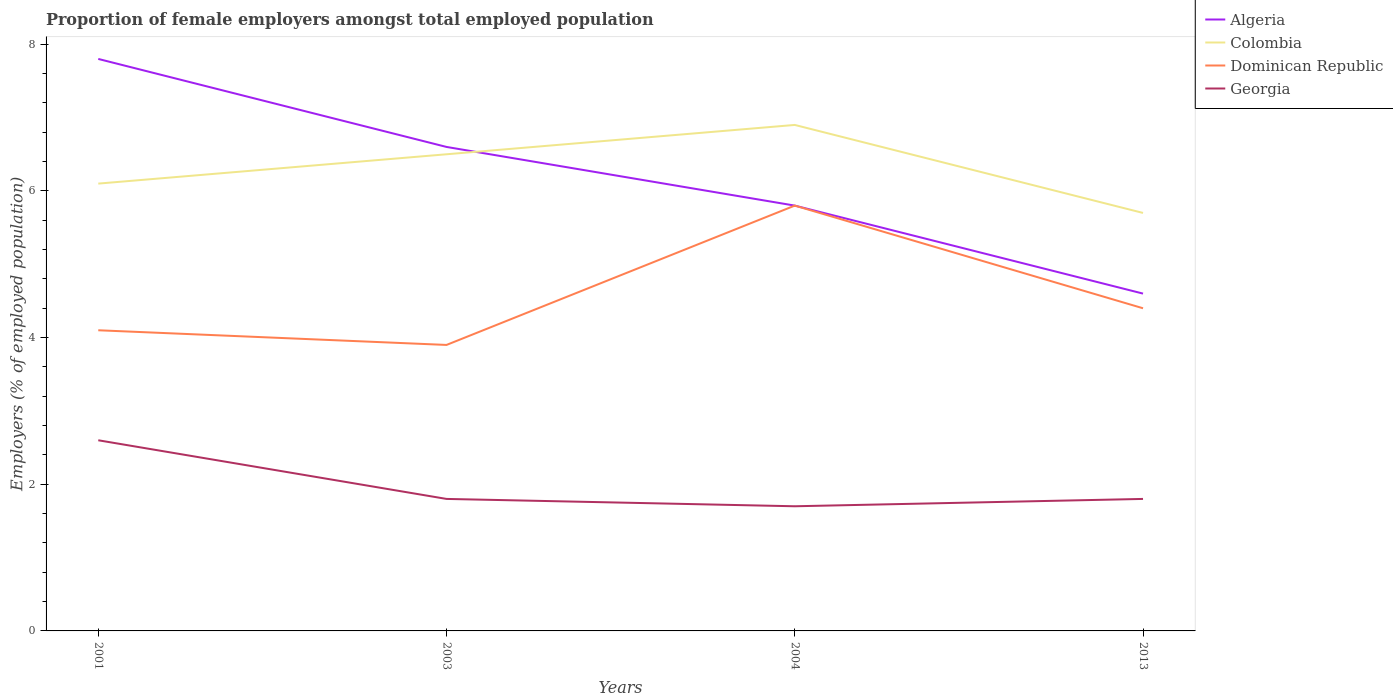How many different coloured lines are there?
Keep it short and to the point. 4. Across all years, what is the maximum proportion of female employers in Dominican Republic?
Keep it short and to the point. 3.9. What is the total proportion of female employers in Dominican Republic in the graph?
Your response must be concise. -0.5. What is the difference between the highest and the second highest proportion of female employers in Georgia?
Ensure brevity in your answer.  0.9. What is the difference between the highest and the lowest proportion of female employers in Colombia?
Keep it short and to the point. 2. Is the proportion of female employers in Georgia strictly greater than the proportion of female employers in Dominican Republic over the years?
Ensure brevity in your answer.  Yes. How many years are there in the graph?
Offer a terse response. 4. What is the difference between two consecutive major ticks on the Y-axis?
Offer a very short reply. 2. Are the values on the major ticks of Y-axis written in scientific E-notation?
Offer a very short reply. No. Does the graph contain grids?
Your answer should be compact. No. What is the title of the graph?
Provide a short and direct response. Proportion of female employers amongst total employed population. Does "Bosnia and Herzegovina" appear as one of the legend labels in the graph?
Provide a short and direct response. No. What is the label or title of the X-axis?
Ensure brevity in your answer.  Years. What is the label or title of the Y-axis?
Your response must be concise. Employers (% of employed population). What is the Employers (% of employed population) in Algeria in 2001?
Make the answer very short. 7.8. What is the Employers (% of employed population) in Colombia in 2001?
Provide a short and direct response. 6.1. What is the Employers (% of employed population) in Dominican Republic in 2001?
Ensure brevity in your answer.  4.1. What is the Employers (% of employed population) in Georgia in 2001?
Offer a very short reply. 2.6. What is the Employers (% of employed population) of Algeria in 2003?
Make the answer very short. 6.6. What is the Employers (% of employed population) in Dominican Republic in 2003?
Offer a terse response. 3.9. What is the Employers (% of employed population) of Georgia in 2003?
Your answer should be very brief. 1.8. What is the Employers (% of employed population) of Algeria in 2004?
Make the answer very short. 5.8. What is the Employers (% of employed population) of Colombia in 2004?
Provide a succinct answer. 6.9. What is the Employers (% of employed population) in Dominican Republic in 2004?
Your answer should be very brief. 5.8. What is the Employers (% of employed population) in Georgia in 2004?
Make the answer very short. 1.7. What is the Employers (% of employed population) in Algeria in 2013?
Make the answer very short. 4.6. What is the Employers (% of employed population) of Colombia in 2013?
Keep it short and to the point. 5.7. What is the Employers (% of employed population) in Dominican Republic in 2013?
Your answer should be very brief. 4.4. What is the Employers (% of employed population) in Georgia in 2013?
Give a very brief answer. 1.8. Across all years, what is the maximum Employers (% of employed population) of Algeria?
Ensure brevity in your answer.  7.8. Across all years, what is the maximum Employers (% of employed population) in Colombia?
Make the answer very short. 6.9. Across all years, what is the maximum Employers (% of employed population) of Dominican Republic?
Give a very brief answer. 5.8. Across all years, what is the maximum Employers (% of employed population) of Georgia?
Your answer should be compact. 2.6. Across all years, what is the minimum Employers (% of employed population) of Algeria?
Give a very brief answer. 4.6. Across all years, what is the minimum Employers (% of employed population) of Colombia?
Your answer should be compact. 5.7. Across all years, what is the minimum Employers (% of employed population) of Dominican Republic?
Your answer should be very brief. 3.9. Across all years, what is the minimum Employers (% of employed population) of Georgia?
Your answer should be very brief. 1.7. What is the total Employers (% of employed population) in Algeria in the graph?
Ensure brevity in your answer.  24.8. What is the total Employers (% of employed population) in Colombia in the graph?
Provide a succinct answer. 25.2. What is the total Employers (% of employed population) in Dominican Republic in the graph?
Provide a short and direct response. 18.2. What is the total Employers (% of employed population) of Georgia in the graph?
Your answer should be compact. 7.9. What is the difference between the Employers (% of employed population) of Colombia in 2001 and that in 2003?
Provide a succinct answer. -0.4. What is the difference between the Employers (% of employed population) of Dominican Republic in 2001 and that in 2004?
Keep it short and to the point. -1.7. What is the difference between the Employers (% of employed population) of Algeria in 2001 and that in 2013?
Your response must be concise. 3.2. What is the difference between the Employers (% of employed population) of Colombia in 2001 and that in 2013?
Your answer should be very brief. 0.4. What is the difference between the Employers (% of employed population) of Dominican Republic in 2001 and that in 2013?
Provide a succinct answer. -0.3. What is the difference between the Employers (% of employed population) of Colombia in 2003 and that in 2004?
Your answer should be compact. -0.4. What is the difference between the Employers (% of employed population) of Dominican Republic in 2003 and that in 2004?
Give a very brief answer. -1.9. What is the difference between the Employers (% of employed population) in Georgia in 2003 and that in 2004?
Offer a very short reply. 0.1. What is the difference between the Employers (% of employed population) of Colombia in 2003 and that in 2013?
Your answer should be compact. 0.8. What is the difference between the Employers (% of employed population) in Colombia in 2004 and that in 2013?
Provide a short and direct response. 1.2. What is the difference between the Employers (% of employed population) of Dominican Republic in 2004 and that in 2013?
Provide a short and direct response. 1.4. What is the difference between the Employers (% of employed population) of Algeria in 2001 and the Employers (% of employed population) of Dominican Republic in 2003?
Provide a succinct answer. 3.9. What is the difference between the Employers (% of employed population) of Dominican Republic in 2001 and the Employers (% of employed population) of Georgia in 2003?
Make the answer very short. 2.3. What is the difference between the Employers (% of employed population) in Algeria in 2001 and the Employers (% of employed population) in Dominican Republic in 2004?
Keep it short and to the point. 2. What is the difference between the Employers (% of employed population) of Colombia in 2001 and the Employers (% of employed population) of Dominican Republic in 2004?
Keep it short and to the point. 0.3. What is the difference between the Employers (% of employed population) of Algeria in 2001 and the Employers (% of employed population) of Colombia in 2013?
Provide a short and direct response. 2.1. What is the difference between the Employers (% of employed population) of Algeria in 2001 and the Employers (% of employed population) of Dominican Republic in 2013?
Ensure brevity in your answer.  3.4. What is the difference between the Employers (% of employed population) in Algeria in 2001 and the Employers (% of employed population) in Georgia in 2013?
Give a very brief answer. 6. What is the difference between the Employers (% of employed population) in Dominican Republic in 2001 and the Employers (% of employed population) in Georgia in 2013?
Your answer should be very brief. 2.3. What is the difference between the Employers (% of employed population) in Algeria in 2003 and the Employers (% of employed population) in Colombia in 2004?
Your answer should be very brief. -0.3. What is the difference between the Employers (% of employed population) in Colombia in 2003 and the Employers (% of employed population) in Dominican Republic in 2004?
Your answer should be compact. 0.7. What is the difference between the Employers (% of employed population) in Colombia in 2003 and the Employers (% of employed population) in Georgia in 2004?
Provide a short and direct response. 4.8. What is the difference between the Employers (% of employed population) of Dominican Republic in 2003 and the Employers (% of employed population) of Georgia in 2004?
Make the answer very short. 2.2. What is the difference between the Employers (% of employed population) in Algeria in 2003 and the Employers (% of employed population) in Dominican Republic in 2013?
Provide a short and direct response. 2.2. What is the difference between the Employers (% of employed population) in Algeria in 2003 and the Employers (% of employed population) in Georgia in 2013?
Provide a short and direct response. 4.8. What is the difference between the Employers (% of employed population) of Colombia in 2003 and the Employers (% of employed population) of Dominican Republic in 2013?
Give a very brief answer. 2.1. What is the difference between the Employers (% of employed population) of Colombia in 2003 and the Employers (% of employed population) of Georgia in 2013?
Offer a very short reply. 4.7. What is the difference between the Employers (% of employed population) of Dominican Republic in 2003 and the Employers (% of employed population) of Georgia in 2013?
Provide a short and direct response. 2.1. What is the difference between the Employers (% of employed population) of Algeria in 2004 and the Employers (% of employed population) of Colombia in 2013?
Offer a terse response. 0.1. What is the difference between the Employers (% of employed population) in Colombia in 2004 and the Employers (% of employed population) in Georgia in 2013?
Provide a short and direct response. 5.1. What is the difference between the Employers (% of employed population) of Dominican Republic in 2004 and the Employers (% of employed population) of Georgia in 2013?
Make the answer very short. 4. What is the average Employers (% of employed population) in Dominican Republic per year?
Make the answer very short. 4.55. What is the average Employers (% of employed population) in Georgia per year?
Provide a short and direct response. 1.98. In the year 2001, what is the difference between the Employers (% of employed population) in Algeria and Employers (% of employed population) in Dominican Republic?
Your answer should be very brief. 3.7. In the year 2001, what is the difference between the Employers (% of employed population) in Colombia and Employers (% of employed population) in Dominican Republic?
Keep it short and to the point. 2. In the year 2003, what is the difference between the Employers (% of employed population) in Algeria and Employers (% of employed population) in Colombia?
Provide a succinct answer. 0.1. In the year 2003, what is the difference between the Employers (% of employed population) in Algeria and Employers (% of employed population) in Georgia?
Your response must be concise. 4.8. In the year 2003, what is the difference between the Employers (% of employed population) of Dominican Republic and Employers (% of employed population) of Georgia?
Keep it short and to the point. 2.1. In the year 2004, what is the difference between the Employers (% of employed population) in Algeria and Employers (% of employed population) in Georgia?
Provide a succinct answer. 4.1. In the year 2004, what is the difference between the Employers (% of employed population) of Dominican Republic and Employers (% of employed population) of Georgia?
Provide a succinct answer. 4.1. In the year 2013, what is the difference between the Employers (% of employed population) of Algeria and Employers (% of employed population) of Colombia?
Provide a short and direct response. -1.1. In the year 2013, what is the difference between the Employers (% of employed population) in Algeria and Employers (% of employed population) in Dominican Republic?
Offer a terse response. 0.2. In the year 2013, what is the difference between the Employers (% of employed population) of Colombia and Employers (% of employed population) of Dominican Republic?
Your response must be concise. 1.3. In the year 2013, what is the difference between the Employers (% of employed population) in Dominican Republic and Employers (% of employed population) in Georgia?
Provide a short and direct response. 2.6. What is the ratio of the Employers (% of employed population) of Algeria in 2001 to that in 2003?
Give a very brief answer. 1.18. What is the ratio of the Employers (% of employed population) of Colombia in 2001 to that in 2003?
Ensure brevity in your answer.  0.94. What is the ratio of the Employers (% of employed population) in Dominican Republic in 2001 to that in 2003?
Provide a succinct answer. 1.05. What is the ratio of the Employers (% of employed population) in Georgia in 2001 to that in 2003?
Offer a very short reply. 1.44. What is the ratio of the Employers (% of employed population) of Algeria in 2001 to that in 2004?
Provide a short and direct response. 1.34. What is the ratio of the Employers (% of employed population) in Colombia in 2001 to that in 2004?
Give a very brief answer. 0.88. What is the ratio of the Employers (% of employed population) in Dominican Republic in 2001 to that in 2004?
Ensure brevity in your answer.  0.71. What is the ratio of the Employers (% of employed population) of Georgia in 2001 to that in 2004?
Your response must be concise. 1.53. What is the ratio of the Employers (% of employed population) in Algeria in 2001 to that in 2013?
Offer a terse response. 1.7. What is the ratio of the Employers (% of employed population) in Colombia in 2001 to that in 2013?
Your response must be concise. 1.07. What is the ratio of the Employers (% of employed population) in Dominican Republic in 2001 to that in 2013?
Ensure brevity in your answer.  0.93. What is the ratio of the Employers (% of employed population) of Georgia in 2001 to that in 2013?
Ensure brevity in your answer.  1.44. What is the ratio of the Employers (% of employed population) in Algeria in 2003 to that in 2004?
Your response must be concise. 1.14. What is the ratio of the Employers (% of employed population) in Colombia in 2003 to that in 2004?
Give a very brief answer. 0.94. What is the ratio of the Employers (% of employed population) in Dominican Republic in 2003 to that in 2004?
Provide a succinct answer. 0.67. What is the ratio of the Employers (% of employed population) of Georgia in 2003 to that in 2004?
Your answer should be very brief. 1.06. What is the ratio of the Employers (% of employed population) of Algeria in 2003 to that in 2013?
Keep it short and to the point. 1.43. What is the ratio of the Employers (% of employed population) in Colombia in 2003 to that in 2013?
Offer a terse response. 1.14. What is the ratio of the Employers (% of employed population) in Dominican Republic in 2003 to that in 2013?
Ensure brevity in your answer.  0.89. What is the ratio of the Employers (% of employed population) in Algeria in 2004 to that in 2013?
Make the answer very short. 1.26. What is the ratio of the Employers (% of employed population) of Colombia in 2004 to that in 2013?
Provide a short and direct response. 1.21. What is the ratio of the Employers (% of employed population) in Dominican Republic in 2004 to that in 2013?
Give a very brief answer. 1.32. What is the difference between the highest and the second highest Employers (% of employed population) in Colombia?
Ensure brevity in your answer.  0.4. What is the difference between the highest and the second highest Employers (% of employed population) in Dominican Republic?
Provide a succinct answer. 1.4. What is the difference between the highest and the lowest Employers (% of employed population) of Colombia?
Your response must be concise. 1.2. What is the difference between the highest and the lowest Employers (% of employed population) of Dominican Republic?
Your answer should be compact. 1.9. What is the difference between the highest and the lowest Employers (% of employed population) of Georgia?
Make the answer very short. 0.9. 